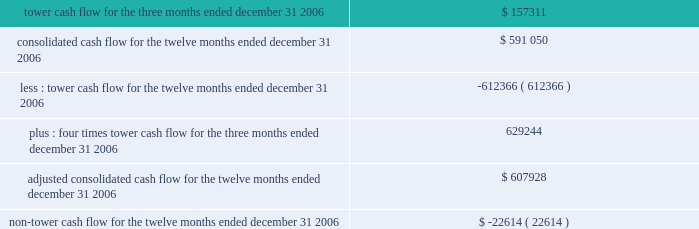In february 2007 , the fasb issued sfas no .
159 201cthe fair value option for financial assets and liabilities 2014including an amendment of fasb statement no .
115 201d ( sfas no .
159 ) .
This statement provides companies with an option to report selected financial assets and liabilities at fair value and establishes presentation and disclosure requirements designed to facilitate comparisons between companies that choose different measurement attributes for similar types of assets and liabilities .
Sfas no .
159 is effective for us as of january 1 , 2008 .
We are in the process of evaluating the impact that sfas no .
159 will have on our consolidated financial statements .
Information presented pursuant to the indentures of our 7.50% ( 7.50 % ) notes , 7.125% ( 7.125 % ) notes and ati 7.25% ( 7.25 % ) the table sets forth information that is presented solely to address certain tower cash flow reporting requirements contained in the indentures for our 7.50% ( 7.50 % ) notes , 7.125% ( 7.125 % ) notes and ati 7.25% ( 7.25 % ) notes ( collectively , the notes ) .
The information contained in note 20 to our consolidated financial statements is also presented to address certain reporting requirements contained in the indenture for our ati 7.25% ( 7.25 % ) notes .
The indentures governing the notes contain restrictive covenants with which we and certain subsidiaries under these indentures must comply .
These include restrictions on our ability to incur additional debt , guarantee debt , pay dividends and make other distributions and make certain investments .
Any failure to comply with these covenants would constitute a default , which could result in the acceleration of the principal amount and accrued and unpaid interest on all the outstanding notes .
In order for the holders of the notes to assess our compliance with certain of these covenants , the indentures require us to disclose in the periodic reports we file with the sec our tower cash flow , adjusted consolidated cash flow and non-tower cash flow ( each as defined in the indentures ) .
Under the indentures , our ability to make certain types of restricted payments is limited by the amount of adjusted consolidated cash flow that we generate , which is determined based on our tower cash flow and non-tower cash flow .
In addition , the indentures for the notes restrict us from incurring additional debt or issuing certain types of preferred stock if on a pro forma basis the issuance of such debt and preferred stock would cause our consolidated debt to be greater than 7.5 times our adjusted consolidated cash flow .
As of december 31 , 2006 , the ratio of our consolidated debt to adjusted consolidated cash flow was approximately 4.6 .
For more information about the restrictions under our notes indentures , see note 7 to our consolidated financial statements included in this annual report and the section entitled 201cmanagement 2019s discussion and analysis of financial condition and results of operations 2014liquidity and capital resources 2014factors affecting sources of liquidity . 201d tower cash flow , adjusted consolidated cash flow and non-tower cash flow are considered non-gaap financial measures .
We are required to provide these financial metrics by the indentures for the notes , and we have included them below because we consider the indentures for the notes to be material agreements , the covenants related to tower cash flow , adjusted consolidated cash flow and non-tower cash flow to be material terms of the indentures , and information about compliance with such covenants to be material to an investor 2019s understanding of our financial results and the impact of those results on our liquidity .
These financial metrics do not include the results of spectrasite or its subsidiaries because such entities are unrestricted subsidiaries under the indentures for the notes .
The table presents tower cash flow , adjusted consolidated cash flow and non-tower cash flow for the company and its restricted subsidiaries , as defined in the indentures for the applicable notes ( in thousands ) : .

What portion of the adjusted consolidated cash flow for the twelve months ended december 31 , 2006 is related to non-tower cash flow? 
Computations: (-22614 / 607928)
Answer: -0.0372. 